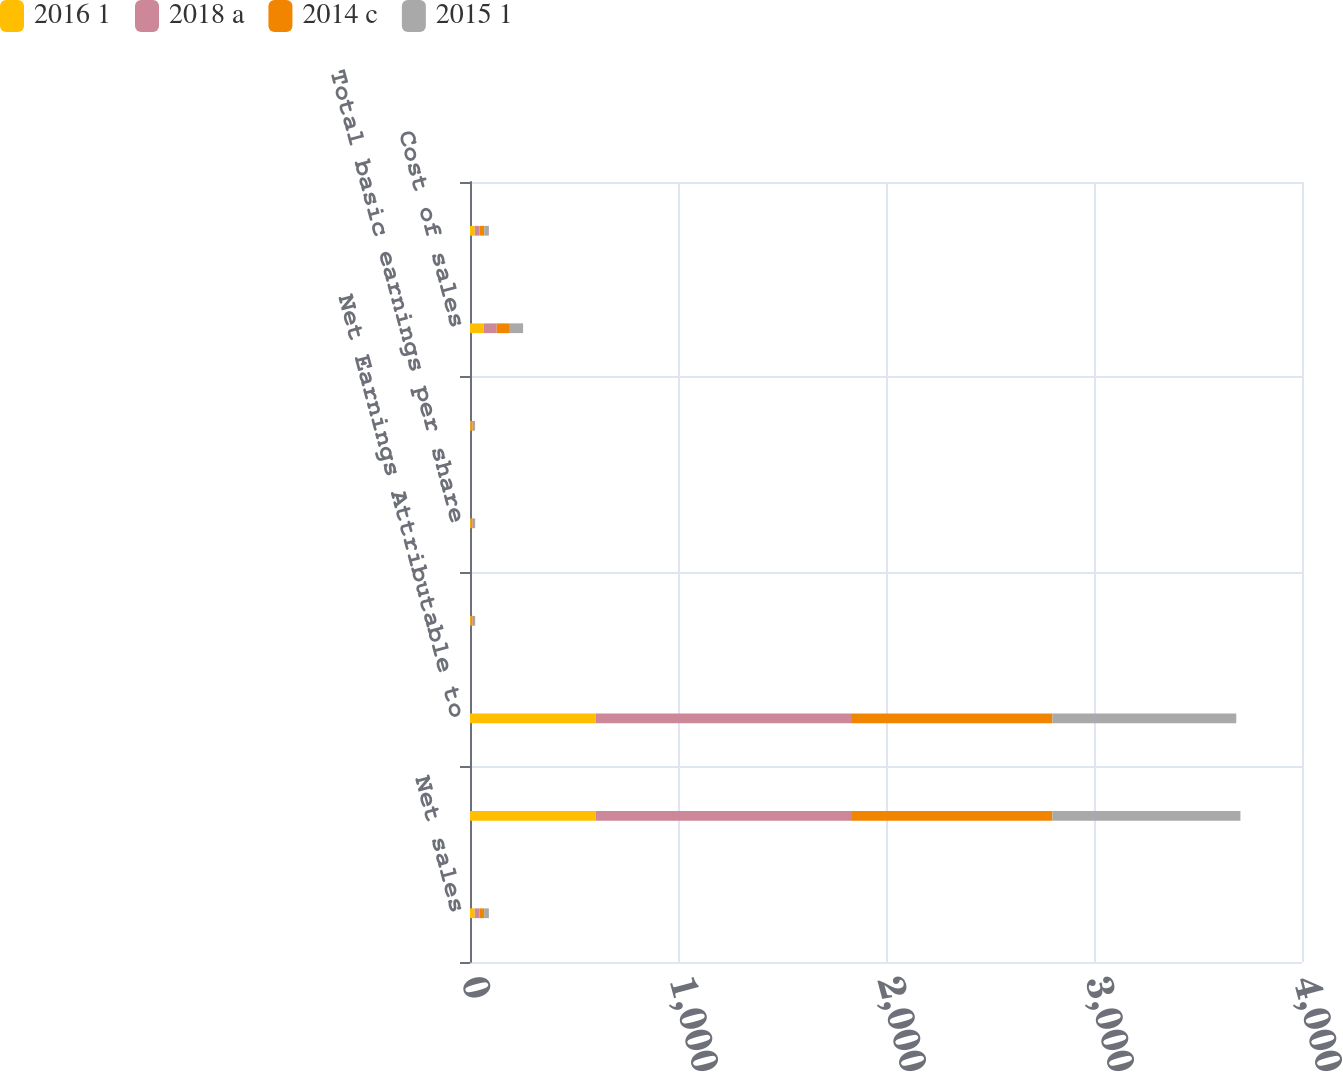Convert chart to OTSL. <chart><loc_0><loc_0><loc_500><loc_500><stacked_bar_chart><ecel><fcel>Net sales<fcel>Net earnings from continuing<fcel>Net Earnings Attributable to<fcel>Continuing operations<fcel>Total basic earnings per share<fcel>Total diluted earnings per<fcel>Cost of sales<fcel>Selling general and<nl><fcel>2016 1<fcel>22.7<fcel>605<fcel>605<fcel>4.06<fcel>4.06<fcel>3.99<fcel>65.3<fcel>22.7<nl><fcel>2018 a<fcel>22.7<fcel>1227<fcel>1227<fcel>8.2<fcel>8.2<fcel>8.05<fcel>63.1<fcel>23.1<nl><fcel>2014 c<fcel>22.7<fcel>968<fcel>968<fcel>6.63<fcel>6.63<fcel>6.53<fcel>63.2<fcel>22.7<nl><fcel>2015 1<fcel>22.7<fcel>904<fcel>884<fcel>6.1<fcel>5.96<fcel>5.79<fcel>63.6<fcel>22.3<nl></chart> 